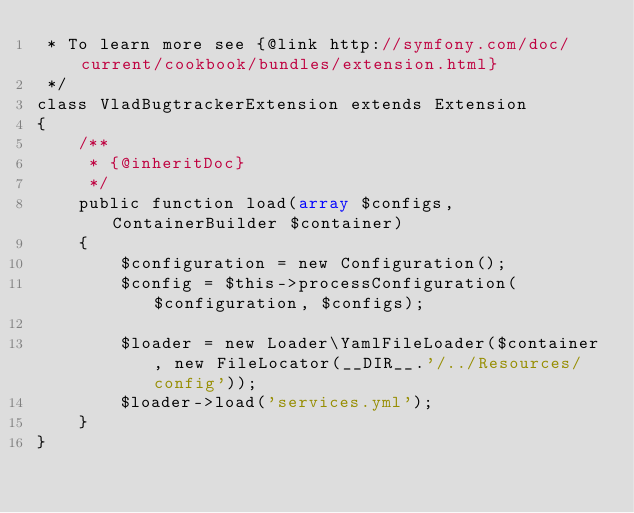Convert code to text. <code><loc_0><loc_0><loc_500><loc_500><_PHP_> * To learn more see {@link http://symfony.com/doc/current/cookbook/bundles/extension.html}
 */
class VladBugtrackerExtension extends Extension
{
    /**
     * {@inheritDoc}
     */
    public function load(array $configs, ContainerBuilder $container)
    {
        $configuration = new Configuration();
        $config = $this->processConfiguration($configuration, $configs);

        $loader = new Loader\YamlFileLoader($container, new FileLocator(__DIR__.'/../Resources/config'));
        $loader->load('services.yml');
    }
}
</code> 